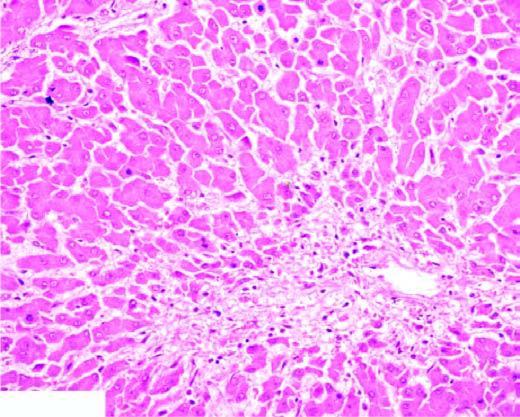does the cytoplasm show marked degeneration and necrosis of hepatocytes accompanied by haemorrhage while the peripheral zone shows mild fatty change of liver cells?
Answer the question using a single word or phrase. No 